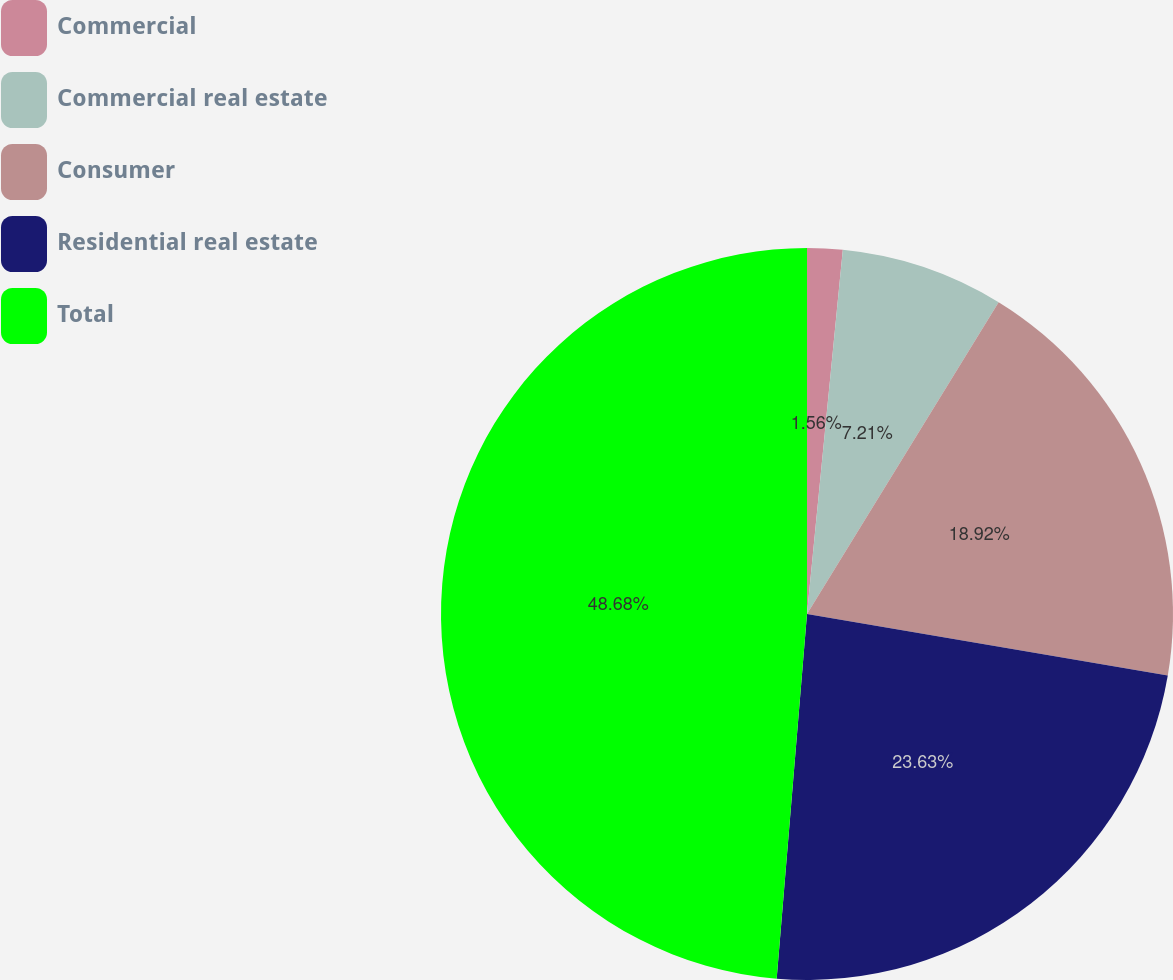<chart> <loc_0><loc_0><loc_500><loc_500><pie_chart><fcel>Commercial<fcel>Commercial real estate<fcel>Consumer<fcel>Residential real estate<fcel>Total<nl><fcel>1.56%<fcel>7.21%<fcel>18.92%<fcel>23.63%<fcel>48.68%<nl></chart> 